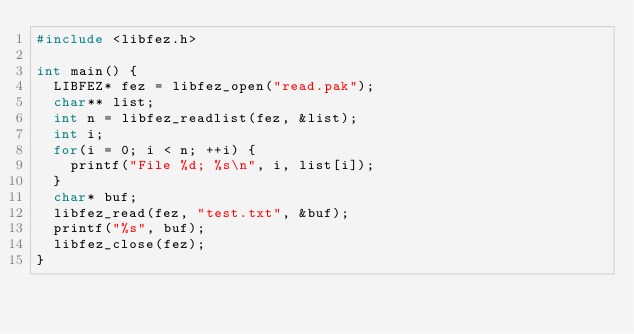Convert code to text. <code><loc_0><loc_0><loc_500><loc_500><_C_>#include <libfez.h>

int main() {
  LIBFEZ* fez = libfez_open("read.pak");
  char** list;
  int n = libfez_readlist(fez, &list);
  int i;
  for(i = 0; i < n; ++i) {
    printf("File %d; %s\n", i, list[i]);
  }
  char* buf;
  libfez_read(fez, "test.txt", &buf);
  printf("%s", buf);
  libfez_close(fez);
}
</code> 